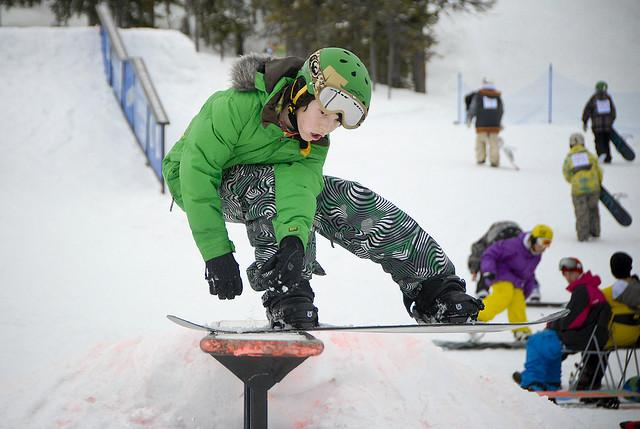Who watches these people while they board on snow? Please explain your reasoning. judges. The judges watch. 